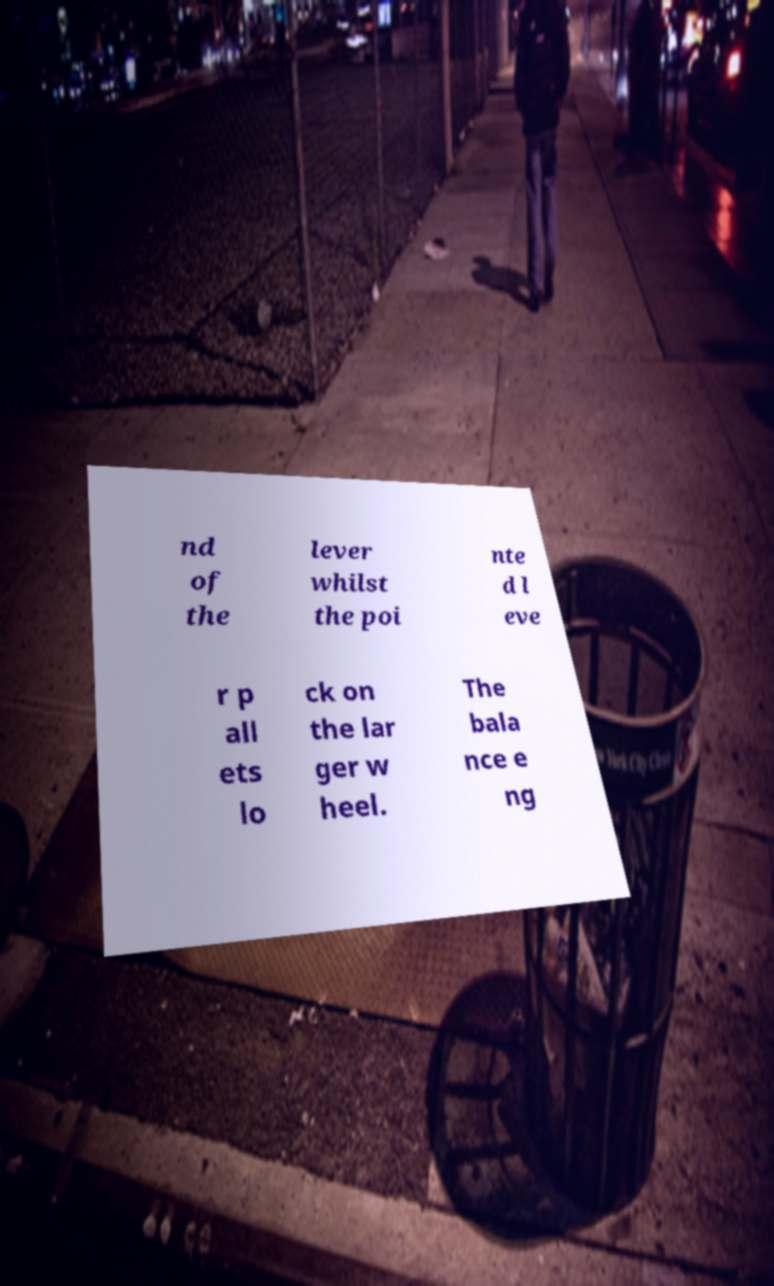Please identify and transcribe the text found in this image. nd of the lever whilst the poi nte d l eve r p all ets lo ck on the lar ger w heel. The bala nce e ng 